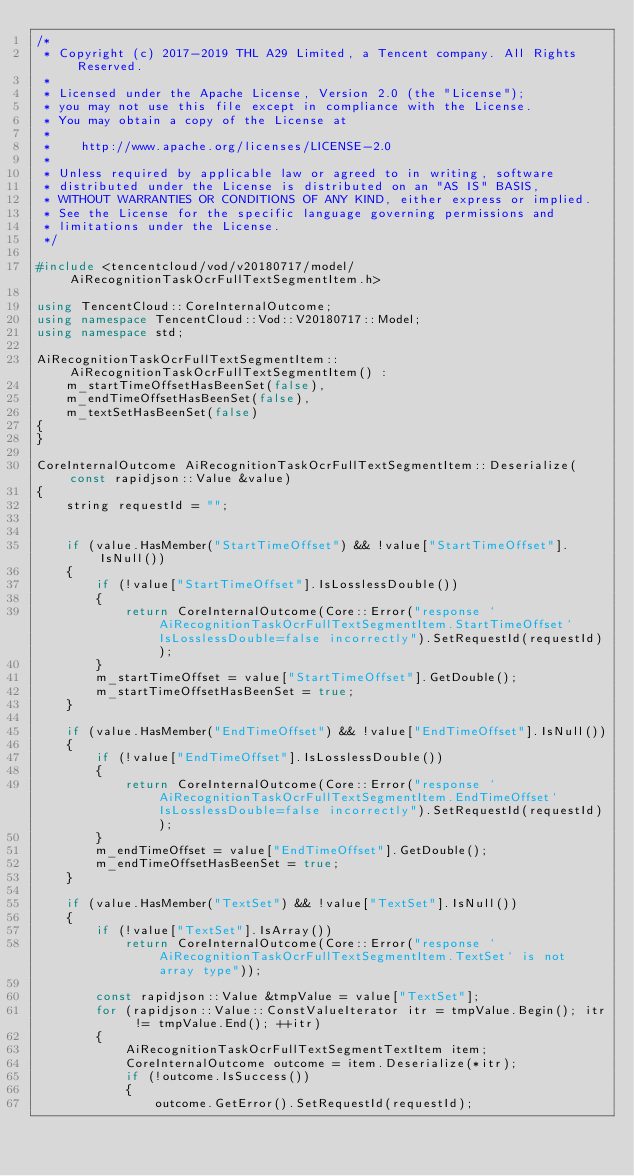Convert code to text. <code><loc_0><loc_0><loc_500><loc_500><_C++_>/*
 * Copyright (c) 2017-2019 THL A29 Limited, a Tencent company. All Rights Reserved.
 *
 * Licensed under the Apache License, Version 2.0 (the "License");
 * you may not use this file except in compliance with the License.
 * You may obtain a copy of the License at
 *
 *    http://www.apache.org/licenses/LICENSE-2.0
 *
 * Unless required by applicable law or agreed to in writing, software
 * distributed under the License is distributed on an "AS IS" BASIS,
 * WITHOUT WARRANTIES OR CONDITIONS OF ANY KIND, either express or implied.
 * See the License for the specific language governing permissions and
 * limitations under the License.
 */

#include <tencentcloud/vod/v20180717/model/AiRecognitionTaskOcrFullTextSegmentItem.h>

using TencentCloud::CoreInternalOutcome;
using namespace TencentCloud::Vod::V20180717::Model;
using namespace std;

AiRecognitionTaskOcrFullTextSegmentItem::AiRecognitionTaskOcrFullTextSegmentItem() :
    m_startTimeOffsetHasBeenSet(false),
    m_endTimeOffsetHasBeenSet(false),
    m_textSetHasBeenSet(false)
{
}

CoreInternalOutcome AiRecognitionTaskOcrFullTextSegmentItem::Deserialize(const rapidjson::Value &value)
{
    string requestId = "";


    if (value.HasMember("StartTimeOffset") && !value["StartTimeOffset"].IsNull())
    {
        if (!value["StartTimeOffset"].IsLosslessDouble())
        {
            return CoreInternalOutcome(Core::Error("response `AiRecognitionTaskOcrFullTextSegmentItem.StartTimeOffset` IsLosslessDouble=false incorrectly").SetRequestId(requestId));
        }
        m_startTimeOffset = value["StartTimeOffset"].GetDouble();
        m_startTimeOffsetHasBeenSet = true;
    }

    if (value.HasMember("EndTimeOffset") && !value["EndTimeOffset"].IsNull())
    {
        if (!value["EndTimeOffset"].IsLosslessDouble())
        {
            return CoreInternalOutcome(Core::Error("response `AiRecognitionTaskOcrFullTextSegmentItem.EndTimeOffset` IsLosslessDouble=false incorrectly").SetRequestId(requestId));
        }
        m_endTimeOffset = value["EndTimeOffset"].GetDouble();
        m_endTimeOffsetHasBeenSet = true;
    }

    if (value.HasMember("TextSet") && !value["TextSet"].IsNull())
    {
        if (!value["TextSet"].IsArray())
            return CoreInternalOutcome(Core::Error("response `AiRecognitionTaskOcrFullTextSegmentItem.TextSet` is not array type"));

        const rapidjson::Value &tmpValue = value["TextSet"];
        for (rapidjson::Value::ConstValueIterator itr = tmpValue.Begin(); itr != tmpValue.End(); ++itr)
        {
            AiRecognitionTaskOcrFullTextSegmentTextItem item;
            CoreInternalOutcome outcome = item.Deserialize(*itr);
            if (!outcome.IsSuccess())
            {
                outcome.GetError().SetRequestId(requestId);</code> 